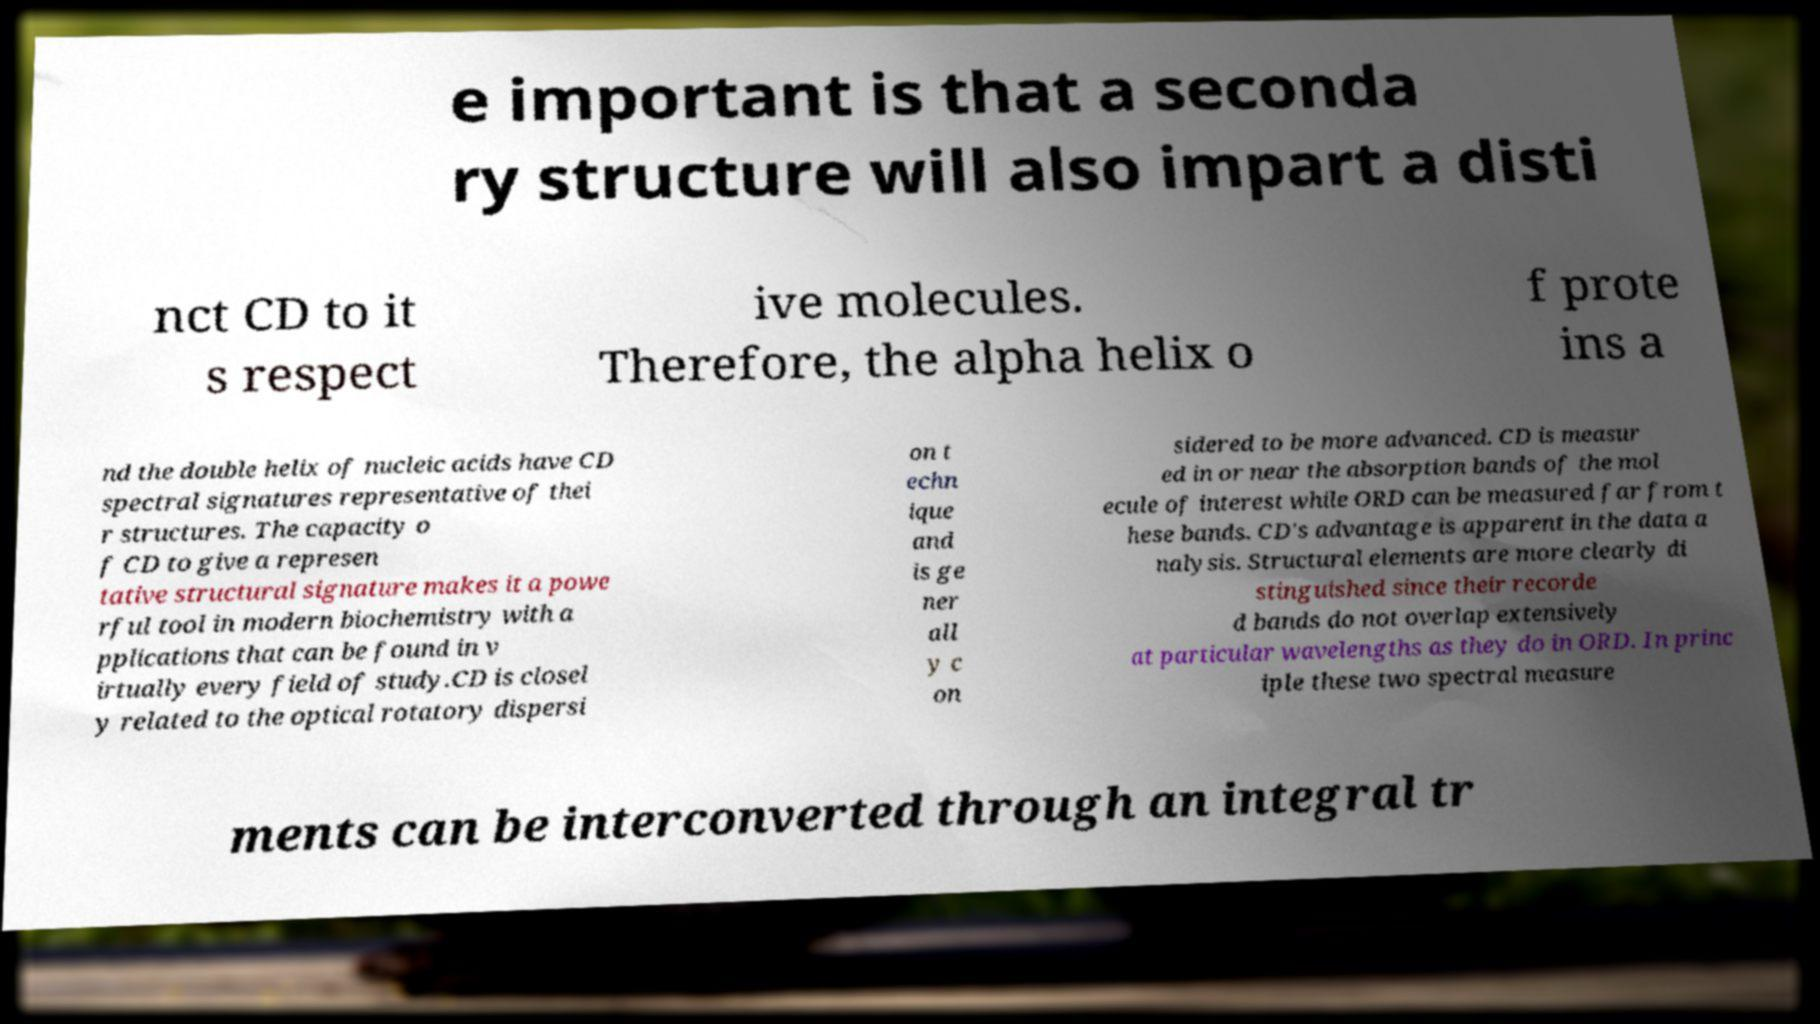What messages or text are displayed in this image? I need them in a readable, typed format. e important is that a seconda ry structure will also impart a disti nct CD to it s respect ive molecules. Therefore, the alpha helix o f prote ins a nd the double helix of nucleic acids have CD spectral signatures representative of thei r structures. The capacity o f CD to give a represen tative structural signature makes it a powe rful tool in modern biochemistry with a pplications that can be found in v irtually every field of study.CD is closel y related to the optical rotatory dispersi on t echn ique and is ge ner all y c on sidered to be more advanced. CD is measur ed in or near the absorption bands of the mol ecule of interest while ORD can be measured far from t hese bands. CD's advantage is apparent in the data a nalysis. Structural elements are more clearly di stinguished since their recorde d bands do not overlap extensively at particular wavelengths as they do in ORD. In princ iple these two spectral measure ments can be interconverted through an integral tr 